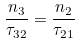<formula> <loc_0><loc_0><loc_500><loc_500>\frac { n _ { 3 } } { \tau _ { 3 2 } } = \frac { n _ { 2 } } { \tau _ { 2 1 } }</formula> 